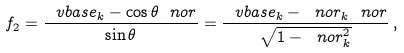<formula> <loc_0><loc_0><loc_500><loc_500>f _ { 2 } = \frac { \ v b a s e _ { k } - \cos \theta \ n o r } { \sin \theta } = \frac { \ v b a s e _ { k } - \ n o r _ { k } \ n o r } { \sqrt { 1 - \ n o r _ { k } ^ { 2 } } } \, ,</formula> 